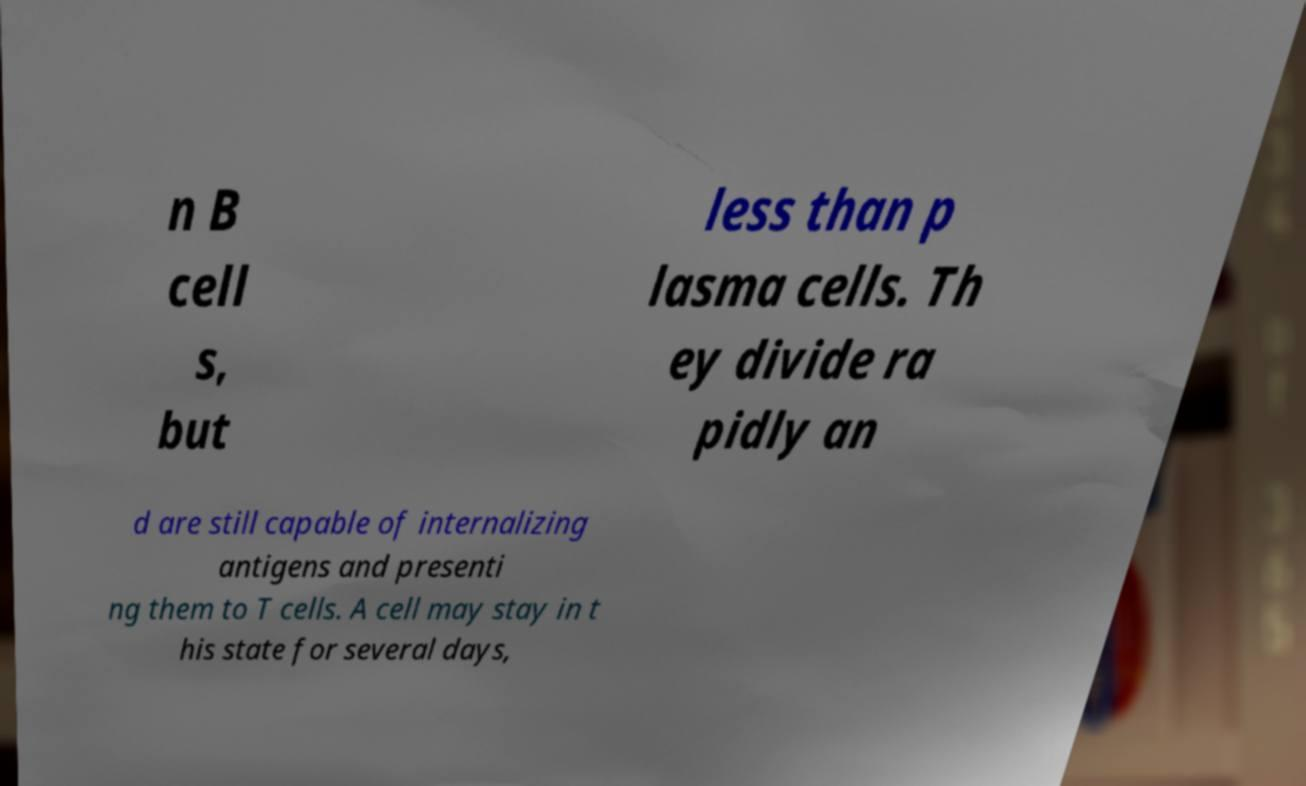What messages or text are displayed in this image? I need them in a readable, typed format. n B cell s, but less than p lasma cells. Th ey divide ra pidly an d are still capable of internalizing antigens and presenti ng them to T cells. A cell may stay in t his state for several days, 